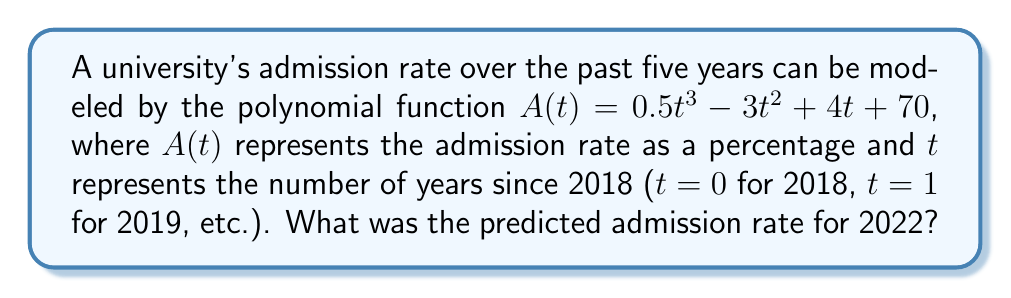Help me with this question. To find the predicted admission rate for 2022, we need to evaluate the function $A(t)$ at $t = 4$, since 2022 is 4 years after 2018.

Let's substitute $t = 4$ into the given function:

$A(4) = 0.5(4)^3 - 3(4)^2 + 4(4) + 70$

Now, let's evaluate step by step:

1) First, calculate the cubic term:
   $0.5(4)^3 = 0.5 \cdot 64 = 32$

2) Next, calculate the quadratic term:
   $-3(4)^2 = -3 \cdot 16 = -48$

3) Then, calculate the linear term:
   $4(4) = 16$

4) Now, add all terms together:
   $32 - 48 + 16 + 70 = 70$

Therefore, the predicted admission rate for 2022 is 70%.
Answer: 70% 